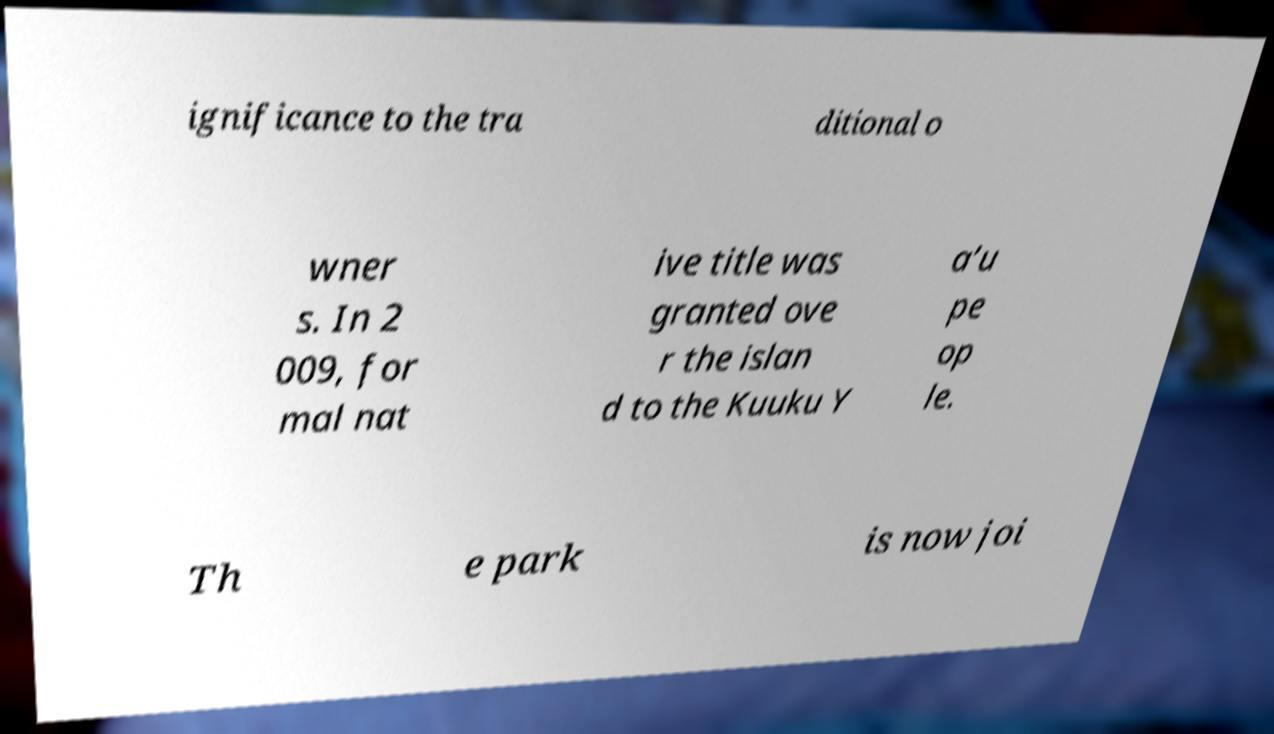Please identify and transcribe the text found in this image. ignificance to the tra ditional o wner s. In 2 009, for mal nat ive title was granted ove r the islan d to the Kuuku Y a’u pe op le. Th e park is now joi 